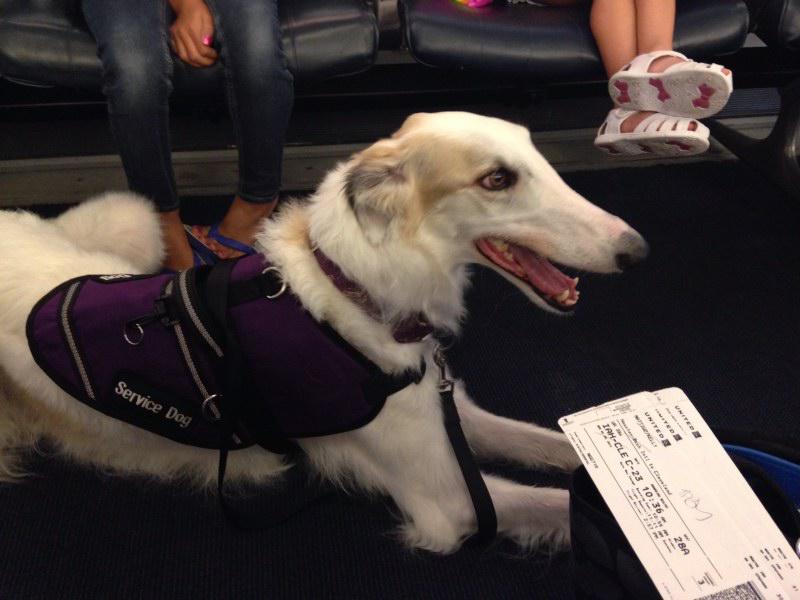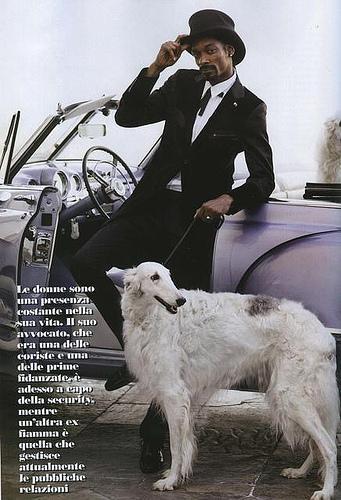The first image is the image on the left, the second image is the image on the right. Assess this claim about the two images: "There is 1 dog facing left in both images.". Correct or not? Answer yes or no. No. The first image is the image on the left, the second image is the image on the right. Assess this claim about the two images: "There is a woman in a denim shirt touching a dog in one of the images.". Correct or not? Answer yes or no. No. 